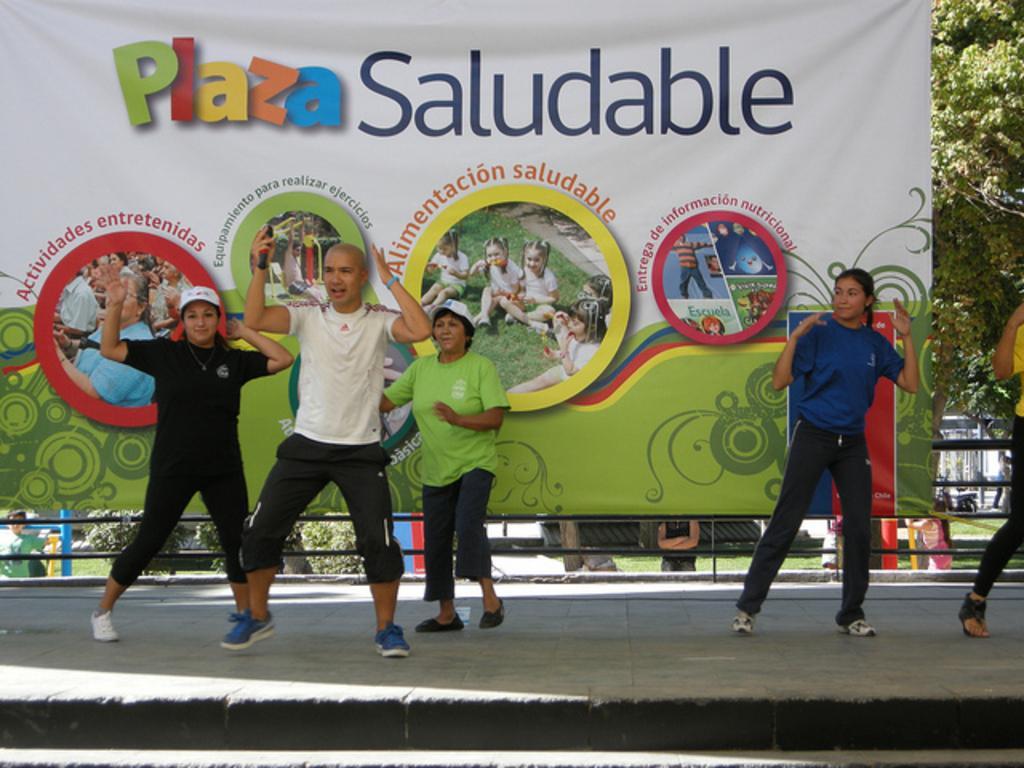Please provide a concise description of this image. In this picture, we see five people are performing dance on the stage. Behind them, we see a banner in white and green color with some text written on it. Behind that, we see the railing and the poles. We see people are standing. In the background, we see the trees and the buildings. 